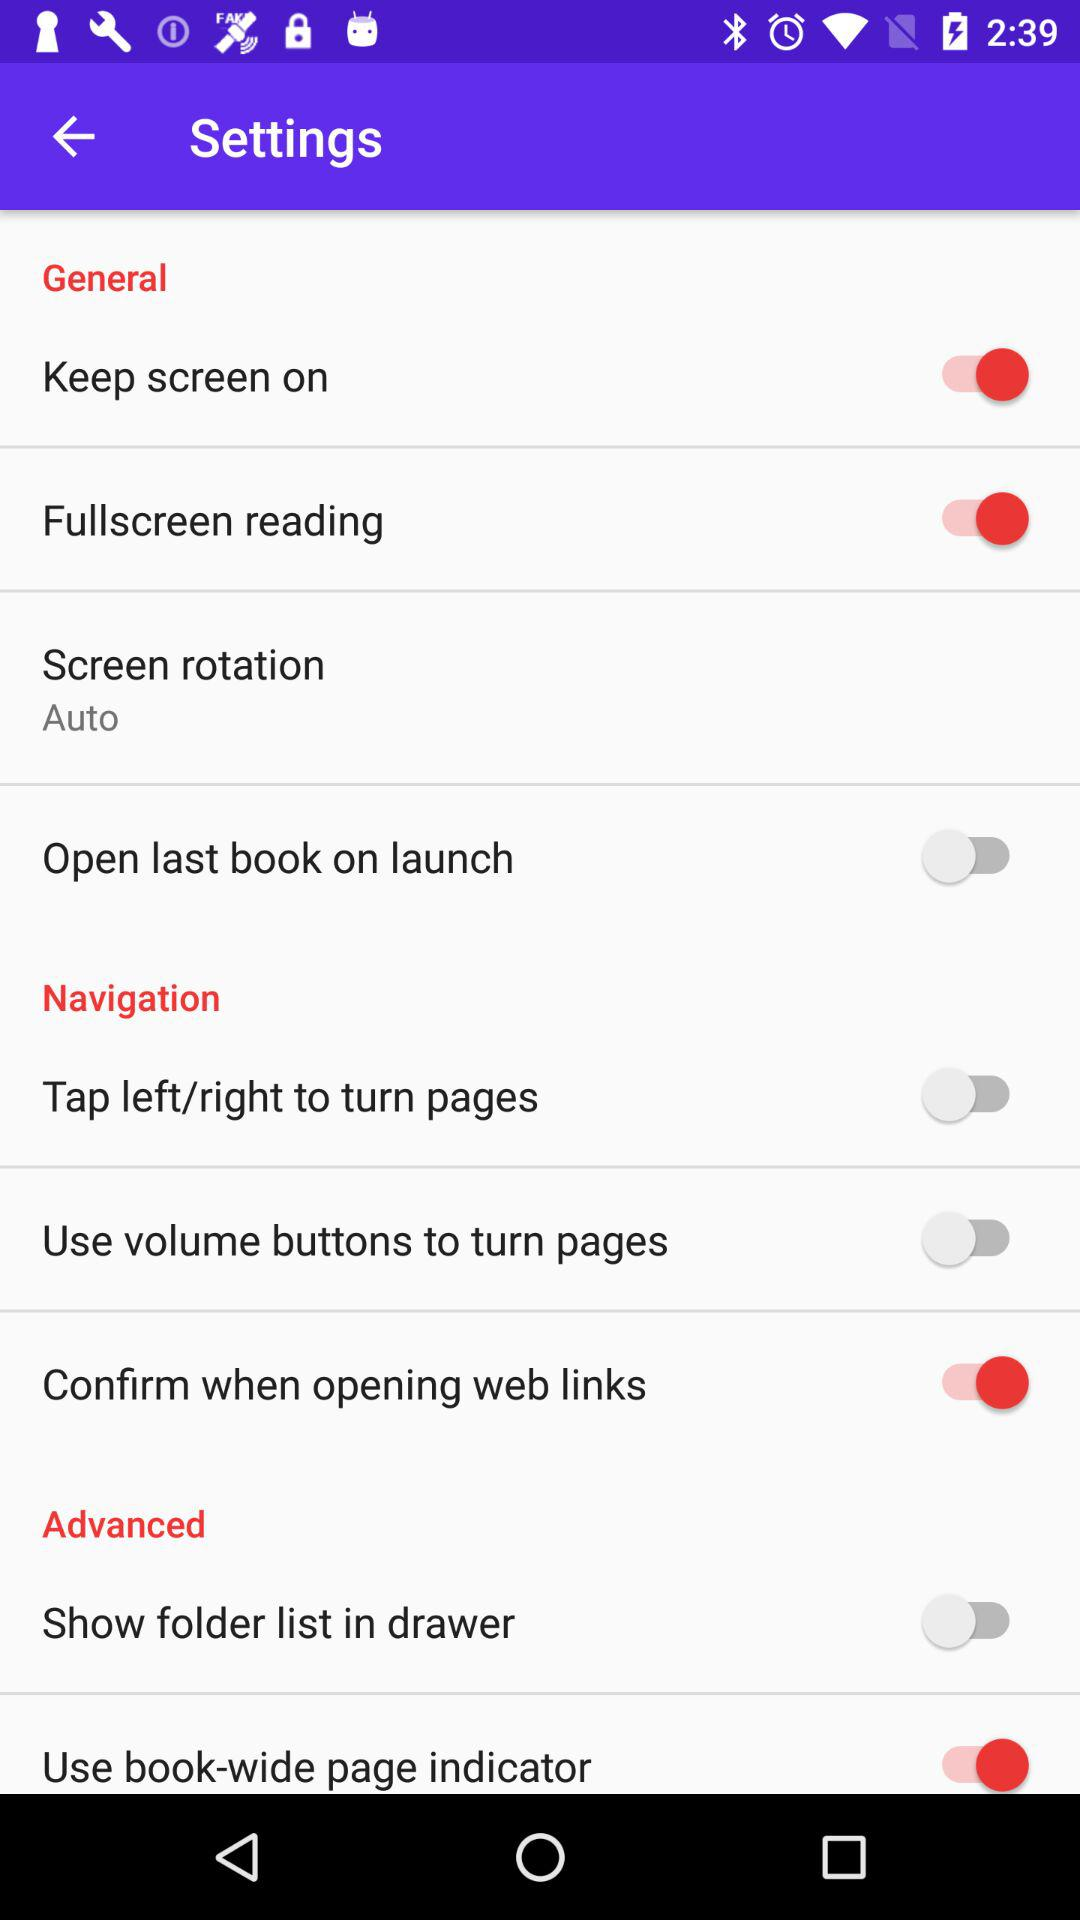What is the current status of "Open last book on launch"? The status of "Open last book on launch" is "off". 